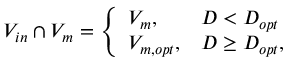<formula> <loc_0><loc_0><loc_500><loc_500>V _ { i n } \cap V _ { m } = \left \{ \begin{array} { l l } { V _ { m } , } & { D < D _ { o p t } } \\ { V _ { m , o p t } , } & { D \geq D _ { o p t } , } \end{array}</formula> 